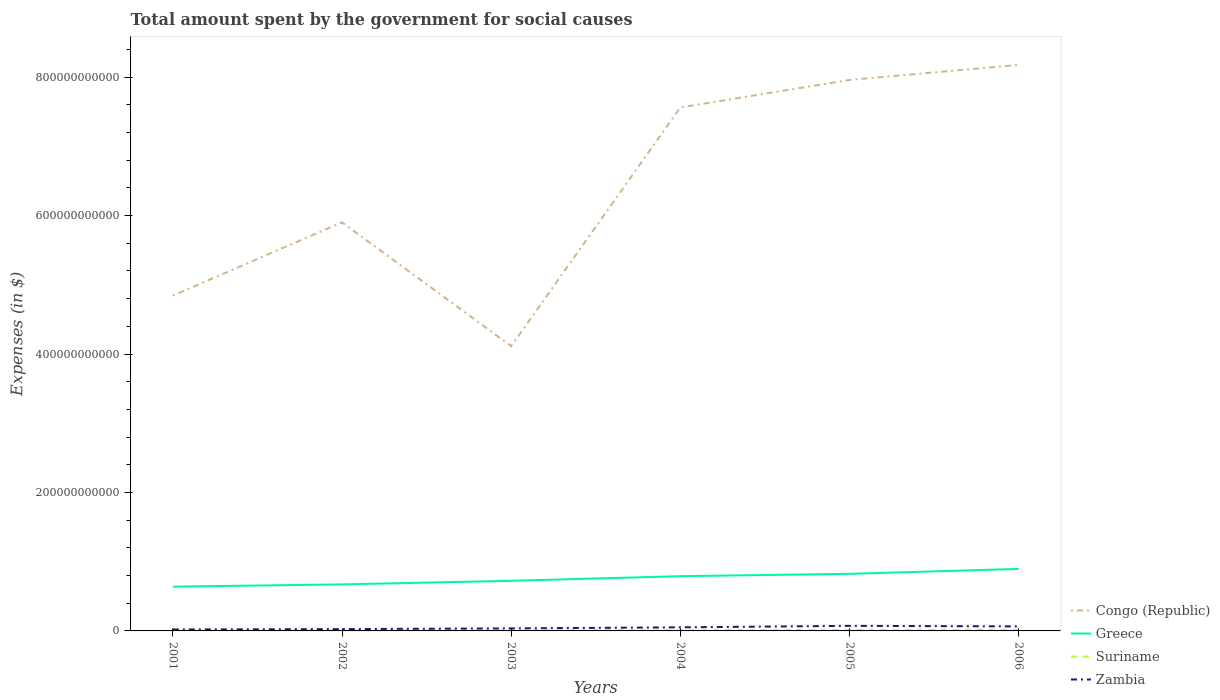Is the number of lines equal to the number of legend labels?
Your answer should be very brief. Yes. Across all years, what is the maximum amount spent for social causes by the government in Congo (Republic)?
Offer a very short reply. 4.11e+11. In which year was the amount spent for social causes by the government in Suriname maximum?
Give a very brief answer. 2001. What is the total amount spent for social causes by the government in Greece in the graph?
Offer a very short reply. -1.01e+1. What is the difference between the highest and the second highest amount spent for social causes by the government in Suriname?
Your answer should be compact. 1.08e+09. What is the difference between the highest and the lowest amount spent for social causes by the government in Congo (Republic)?
Offer a very short reply. 3. How many years are there in the graph?
Keep it short and to the point. 6. What is the difference between two consecutive major ticks on the Y-axis?
Your answer should be compact. 2.00e+11. Are the values on the major ticks of Y-axis written in scientific E-notation?
Your response must be concise. No. Does the graph contain grids?
Give a very brief answer. No. How many legend labels are there?
Your answer should be compact. 4. What is the title of the graph?
Give a very brief answer. Total amount spent by the government for social causes. What is the label or title of the Y-axis?
Make the answer very short. Expenses (in $). What is the Expenses (in $) of Congo (Republic) in 2001?
Offer a very short reply. 4.84e+11. What is the Expenses (in $) in Greece in 2001?
Keep it short and to the point. 6.39e+1. What is the Expenses (in $) in Suriname in 2001?
Your answer should be compact. 5.43e+08. What is the Expenses (in $) of Zambia in 2001?
Give a very brief answer. 2.09e+09. What is the Expenses (in $) in Congo (Republic) in 2002?
Your answer should be compact. 5.90e+11. What is the Expenses (in $) in Greece in 2002?
Make the answer very short. 6.72e+1. What is the Expenses (in $) of Suriname in 2002?
Make the answer very short. 7.52e+08. What is the Expenses (in $) in Zambia in 2002?
Offer a terse response. 2.61e+09. What is the Expenses (in $) in Congo (Republic) in 2003?
Your response must be concise. 4.11e+11. What is the Expenses (in $) in Greece in 2003?
Make the answer very short. 7.24e+1. What is the Expenses (in $) in Suriname in 2003?
Ensure brevity in your answer.  8.44e+08. What is the Expenses (in $) of Zambia in 2003?
Your response must be concise. 3.65e+09. What is the Expenses (in $) of Congo (Republic) in 2004?
Your response must be concise. 7.56e+11. What is the Expenses (in $) in Greece in 2004?
Make the answer very short. 7.91e+1. What is the Expenses (in $) in Suriname in 2004?
Offer a very short reply. 1.07e+09. What is the Expenses (in $) of Zambia in 2004?
Offer a terse response. 5.19e+09. What is the Expenses (in $) in Congo (Republic) in 2005?
Your answer should be very brief. 7.96e+11. What is the Expenses (in $) of Greece in 2005?
Make the answer very short. 8.25e+1. What is the Expenses (in $) in Suriname in 2005?
Give a very brief answer. 1.28e+09. What is the Expenses (in $) of Zambia in 2005?
Offer a very short reply. 7.35e+09. What is the Expenses (in $) in Congo (Republic) in 2006?
Ensure brevity in your answer.  8.18e+11. What is the Expenses (in $) in Greece in 2006?
Offer a terse response. 8.96e+1. What is the Expenses (in $) of Suriname in 2006?
Your response must be concise. 1.63e+09. What is the Expenses (in $) of Zambia in 2006?
Your response must be concise. 6.54e+09. Across all years, what is the maximum Expenses (in $) in Congo (Republic)?
Keep it short and to the point. 8.18e+11. Across all years, what is the maximum Expenses (in $) in Greece?
Make the answer very short. 8.96e+1. Across all years, what is the maximum Expenses (in $) in Suriname?
Ensure brevity in your answer.  1.63e+09. Across all years, what is the maximum Expenses (in $) of Zambia?
Make the answer very short. 7.35e+09. Across all years, what is the minimum Expenses (in $) of Congo (Republic)?
Keep it short and to the point. 4.11e+11. Across all years, what is the minimum Expenses (in $) in Greece?
Your response must be concise. 6.39e+1. Across all years, what is the minimum Expenses (in $) of Suriname?
Make the answer very short. 5.43e+08. Across all years, what is the minimum Expenses (in $) of Zambia?
Offer a terse response. 2.09e+09. What is the total Expenses (in $) of Congo (Republic) in the graph?
Ensure brevity in your answer.  3.86e+12. What is the total Expenses (in $) of Greece in the graph?
Offer a very short reply. 4.55e+11. What is the total Expenses (in $) in Suriname in the graph?
Keep it short and to the point. 6.12e+09. What is the total Expenses (in $) in Zambia in the graph?
Ensure brevity in your answer.  2.74e+1. What is the difference between the Expenses (in $) of Congo (Republic) in 2001 and that in 2002?
Make the answer very short. -1.06e+11. What is the difference between the Expenses (in $) of Greece in 2001 and that in 2002?
Offer a very short reply. -3.33e+09. What is the difference between the Expenses (in $) in Suriname in 2001 and that in 2002?
Your response must be concise. -2.09e+08. What is the difference between the Expenses (in $) in Zambia in 2001 and that in 2002?
Your answer should be very brief. -5.29e+08. What is the difference between the Expenses (in $) in Congo (Republic) in 2001 and that in 2003?
Make the answer very short. 7.30e+1. What is the difference between the Expenses (in $) in Greece in 2001 and that in 2003?
Offer a terse response. -8.49e+09. What is the difference between the Expenses (in $) in Suriname in 2001 and that in 2003?
Your response must be concise. -3.00e+08. What is the difference between the Expenses (in $) in Zambia in 2001 and that in 2003?
Provide a succinct answer. -1.57e+09. What is the difference between the Expenses (in $) of Congo (Republic) in 2001 and that in 2004?
Ensure brevity in your answer.  -2.72e+11. What is the difference between the Expenses (in $) in Greece in 2001 and that in 2004?
Provide a short and direct response. -1.52e+1. What is the difference between the Expenses (in $) in Suriname in 2001 and that in 2004?
Provide a succinct answer. -5.28e+08. What is the difference between the Expenses (in $) in Zambia in 2001 and that in 2004?
Offer a very short reply. -3.10e+09. What is the difference between the Expenses (in $) of Congo (Republic) in 2001 and that in 2005?
Provide a short and direct response. -3.12e+11. What is the difference between the Expenses (in $) of Greece in 2001 and that in 2005?
Your answer should be very brief. -1.86e+1. What is the difference between the Expenses (in $) in Suriname in 2001 and that in 2005?
Make the answer very short. -7.40e+08. What is the difference between the Expenses (in $) of Zambia in 2001 and that in 2005?
Offer a terse response. -5.26e+09. What is the difference between the Expenses (in $) of Congo (Republic) in 2001 and that in 2006?
Provide a short and direct response. -3.33e+11. What is the difference between the Expenses (in $) in Greece in 2001 and that in 2006?
Provide a short and direct response. -2.57e+1. What is the difference between the Expenses (in $) of Suriname in 2001 and that in 2006?
Offer a terse response. -1.08e+09. What is the difference between the Expenses (in $) of Zambia in 2001 and that in 2006?
Your answer should be very brief. -4.46e+09. What is the difference between the Expenses (in $) of Congo (Republic) in 2002 and that in 2003?
Provide a succinct answer. 1.79e+11. What is the difference between the Expenses (in $) of Greece in 2002 and that in 2003?
Your answer should be compact. -5.16e+09. What is the difference between the Expenses (in $) in Suriname in 2002 and that in 2003?
Your response must be concise. -9.11e+07. What is the difference between the Expenses (in $) of Zambia in 2002 and that in 2003?
Ensure brevity in your answer.  -1.04e+09. What is the difference between the Expenses (in $) in Congo (Republic) in 2002 and that in 2004?
Make the answer very short. -1.66e+11. What is the difference between the Expenses (in $) of Greece in 2002 and that in 2004?
Offer a terse response. -1.19e+1. What is the difference between the Expenses (in $) of Suriname in 2002 and that in 2004?
Keep it short and to the point. -3.19e+08. What is the difference between the Expenses (in $) in Zambia in 2002 and that in 2004?
Your answer should be compact. -2.57e+09. What is the difference between the Expenses (in $) of Congo (Republic) in 2002 and that in 2005?
Keep it short and to the point. -2.06e+11. What is the difference between the Expenses (in $) of Greece in 2002 and that in 2005?
Give a very brief answer. -1.52e+1. What is the difference between the Expenses (in $) of Suriname in 2002 and that in 2005?
Provide a succinct answer. -5.31e+08. What is the difference between the Expenses (in $) of Zambia in 2002 and that in 2005?
Your answer should be compact. -4.73e+09. What is the difference between the Expenses (in $) of Congo (Republic) in 2002 and that in 2006?
Your answer should be compact. -2.28e+11. What is the difference between the Expenses (in $) of Greece in 2002 and that in 2006?
Offer a very short reply. -2.23e+1. What is the difference between the Expenses (in $) in Suriname in 2002 and that in 2006?
Ensure brevity in your answer.  -8.74e+08. What is the difference between the Expenses (in $) in Zambia in 2002 and that in 2006?
Your response must be concise. -3.93e+09. What is the difference between the Expenses (in $) of Congo (Republic) in 2003 and that in 2004?
Provide a short and direct response. -3.45e+11. What is the difference between the Expenses (in $) of Greece in 2003 and that in 2004?
Offer a terse response. -6.69e+09. What is the difference between the Expenses (in $) in Suriname in 2003 and that in 2004?
Give a very brief answer. -2.28e+08. What is the difference between the Expenses (in $) in Zambia in 2003 and that in 2004?
Offer a terse response. -1.53e+09. What is the difference between the Expenses (in $) in Congo (Republic) in 2003 and that in 2005?
Offer a very short reply. -3.85e+11. What is the difference between the Expenses (in $) of Greece in 2003 and that in 2005?
Provide a short and direct response. -1.01e+1. What is the difference between the Expenses (in $) in Suriname in 2003 and that in 2005?
Offer a very short reply. -4.39e+08. What is the difference between the Expenses (in $) of Zambia in 2003 and that in 2005?
Keep it short and to the point. -3.69e+09. What is the difference between the Expenses (in $) in Congo (Republic) in 2003 and that in 2006?
Provide a short and direct response. -4.06e+11. What is the difference between the Expenses (in $) in Greece in 2003 and that in 2006?
Provide a short and direct response. -1.72e+1. What is the difference between the Expenses (in $) of Suriname in 2003 and that in 2006?
Offer a very short reply. -7.83e+08. What is the difference between the Expenses (in $) of Zambia in 2003 and that in 2006?
Your answer should be compact. -2.89e+09. What is the difference between the Expenses (in $) of Congo (Republic) in 2004 and that in 2005?
Give a very brief answer. -3.97e+1. What is the difference between the Expenses (in $) of Greece in 2004 and that in 2005?
Provide a short and direct response. -3.38e+09. What is the difference between the Expenses (in $) in Suriname in 2004 and that in 2005?
Make the answer very short. -2.11e+08. What is the difference between the Expenses (in $) in Zambia in 2004 and that in 2005?
Offer a terse response. -2.16e+09. What is the difference between the Expenses (in $) in Congo (Republic) in 2004 and that in 2006?
Give a very brief answer. -6.15e+1. What is the difference between the Expenses (in $) in Greece in 2004 and that in 2006?
Give a very brief answer. -1.05e+1. What is the difference between the Expenses (in $) of Suriname in 2004 and that in 2006?
Keep it short and to the point. -5.55e+08. What is the difference between the Expenses (in $) in Zambia in 2004 and that in 2006?
Your answer should be very brief. -1.36e+09. What is the difference between the Expenses (in $) in Congo (Republic) in 2005 and that in 2006?
Ensure brevity in your answer.  -2.18e+1. What is the difference between the Expenses (in $) of Greece in 2005 and that in 2006?
Provide a succinct answer. -7.10e+09. What is the difference between the Expenses (in $) in Suriname in 2005 and that in 2006?
Provide a succinct answer. -3.43e+08. What is the difference between the Expenses (in $) in Zambia in 2005 and that in 2006?
Offer a very short reply. 8.04e+08. What is the difference between the Expenses (in $) in Congo (Republic) in 2001 and the Expenses (in $) in Greece in 2002?
Provide a short and direct response. 4.17e+11. What is the difference between the Expenses (in $) in Congo (Republic) in 2001 and the Expenses (in $) in Suriname in 2002?
Ensure brevity in your answer.  4.84e+11. What is the difference between the Expenses (in $) of Congo (Republic) in 2001 and the Expenses (in $) of Zambia in 2002?
Your answer should be compact. 4.82e+11. What is the difference between the Expenses (in $) of Greece in 2001 and the Expenses (in $) of Suriname in 2002?
Give a very brief answer. 6.32e+1. What is the difference between the Expenses (in $) of Greece in 2001 and the Expenses (in $) of Zambia in 2002?
Your answer should be compact. 6.13e+1. What is the difference between the Expenses (in $) of Suriname in 2001 and the Expenses (in $) of Zambia in 2002?
Provide a short and direct response. -2.07e+09. What is the difference between the Expenses (in $) in Congo (Republic) in 2001 and the Expenses (in $) in Greece in 2003?
Your answer should be compact. 4.12e+11. What is the difference between the Expenses (in $) of Congo (Republic) in 2001 and the Expenses (in $) of Suriname in 2003?
Provide a short and direct response. 4.84e+11. What is the difference between the Expenses (in $) in Congo (Republic) in 2001 and the Expenses (in $) in Zambia in 2003?
Make the answer very short. 4.81e+11. What is the difference between the Expenses (in $) of Greece in 2001 and the Expenses (in $) of Suriname in 2003?
Your answer should be very brief. 6.31e+1. What is the difference between the Expenses (in $) of Greece in 2001 and the Expenses (in $) of Zambia in 2003?
Make the answer very short. 6.03e+1. What is the difference between the Expenses (in $) in Suriname in 2001 and the Expenses (in $) in Zambia in 2003?
Make the answer very short. -3.11e+09. What is the difference between the Expenses (in $) in Congo (Republic) in 2001 and the Expenses (in $) in Greece in 2004?
Make the answer very short. 4.05e+11. What is the difference between the Expenses (in $) of Congo (Republic) in 2001 and the Expenses (in $) of Suriname in 2004?
Offer a terse response. 4.83e+11. What is the difference between the Expenses (in $) in Congo (Republic) in 2001 and the Expenses (in $) in Zambia in 2004?
Give a very brief answer. 4.79e+11. What is the difference between the Expenses (in $) of Greece in 2001 and the Expenses (in $) of Suriname in 2004?
Make the answer very short. 6.28e+1. What is the difference between the Expenses (in $) of Greece in 2001 and the Expenses (in $) of Zambia in 2004?
Offer a terse response. 5.87e+1. What is the difference between the Expenses (in $) of Suriname in 2001 and the Expenses (in $) of Zambia in 2004?
Make the answer very short. -4.64e+09. What is the difference between the Expenses (in $) of Congo (Republic) in 2001 and the Expenses (in $) of Greece in 2005?
Keep it short and to the point. 4.02e+11. What is the difference between the Expenses (in $) of Congo (Republic) in 2001 and the Expenses (in $) of Suriname in 2005?
Give a very brief answer. 4.83e+11. What is the difference between the Expenses (in $) of Congo (Republic) in 2001 and the Expenses (in $) of Zambia in 2005?
Ensure brevity in your answer.  4.77e+11. What is the difference between the Expenses (in $) in Greece in 2001 and the Expenses (in $) in Suriname in 2005?
Give a very brief answer. 6.26e+1. What is the difference between the Expenses (in $) in Greece in 2001 and the Expenses (in $) in Zambia in 2005?
Make the answer very short. 5.66e+1. What is the difference between the Expenses (in $) of Suriname in 2001 and the Expenses (in $) of Zambia in 2005?
Ensure brevity in your answer.  -6.80e+09. What is the difference between the Expenses (in $) of Congo (Republic) in 2001 and the Expenses (in $) of Greece in 2006?
Offer a terse response. 3.95e+11. What is the difference between the Expenses (in $) in Congo (Republic) in 2001 and the Expenses (in $) in Suriname in 2006?
Your answer should be compact. 4.83e+11. What is the difference between the Expenses (in $) of Congo (Republic) in 2001 and the Expenses (in $) of Zambia in 2006?
Ensure brevity in your answer.  4.78e+11. What is the difference between the Expenses (in $) of Greece in 2001 and the Expenses (in $) of Suriname in 2006?
Ensure brevity in your answer.  6.23e+1. What is the difference between the Expenses (in $) in Greece in 2001 and the Expenses (in $) in Zambia in 2006?
Your response must be concise. 5.74e+1. What is the difference between the Expenses (in $) in Suriname in 2001 and the Expenses (in $) in Zambia in 2006?
Provide a short and direct response. -6.00e+09. What is the difference between the Expenses (in $) in Congo (Republic) in 2002 and the Expenses (in $) in Greece in 2003?
Provide a short and direct response. 5.18e+11. What is the difference between the Expenses (in $) of Congo (Republic) in 2002 and the Expenses (in $) of Suriname in 2003?
Your answer should be compact. 5.89e+11. What is the difference between the Expenses (in $) of Congo (Republic) in 2002 and the Expenses (in $) of Zambia in 2003?
Provide a short and direct response. 5.87e+11. What is the difference between the Expenses (in $) in Greece in 2002 and the Expenses (in $) in Suriname in 2003?
Your answer should be very brief. 6.64e+1. What is the difference between the Expenses (in $) of Greece in 2002 and the Expenses (in $) of Zambia in 2003?
Provide a succinct answer. 6.36e+1. What is the difference between the Expenses (in $) in Suriname in 2002 and the Expenses (in $) in Zambia in 2003?
Your response must be concise. -2.90e+09. What is the difference between the Expenses (in $) of Congo (Republic) in 2002 and the Expenses (in $) of Greece in 2004?
Keep it short and to the point. 5.11e+11. What is the difference between the Expenses (in $) of Congo (Republic) in 2002 and the Expenses (in $) of Suriname in 2004?
Ensure brevity in your answer.  5.89e+11. What is the difference between the Expenses (in $) in Congo (Republic) in 2002 and the Expenses (in $) in Zambia in 2004?
Offer a very short reply. 5.85e+11. What is the difference between the Expenses (in $) of Greece in 2002 and the Expenses (in $) of Suriname in 2004?
Offer a very short reply. 6.62e+1. What is the difference between the Expenses (in $) in Greece in 2002 and the Expenses (in $) in Zambia in 2004?
Your response must be concise. 6.21e+1. What is the difference between the Expenses (in $) of Suriname in 2002 and the Expenses (in $) of Zambia in 2004?
Your answer should be very brief. -4.43e+09. What is the difference between the Expenses (in $) of Congo (Republic) in 2002 and the Expenses (in $) of Greece in 2005?
Offer a very short reply. 5.08e+11. What is the difference between the Expenses (in $) of Congo (Republic) in 2002 and the Expenses (in $) of Suriname in 2005?
Provide a succinct answer. 5.89e+11. What is the difference between the Expenses (in $) of Congo (Republic) in 2002 and the Expenses (in $) of Zambia in 2005?
Ensure brevity in your answer.  5.83e+11. What is the difference between the Expenses (in $) in Greece in 2002 and the Expenses (in $) in Suriname in 2005?
Give a very brief answer. 6.60e+1. What is the difference between the Expenses (in $) in Greece in 2002 and the Expenses (in $) in Zambia in 2005?
Offer a very short reply. 5.99e+1. What is the difference between the Expenses (in $) in Suriname in 2002 and the Expenses (in $) in Zambia in 2005?
Offer a terse response. -6.60e+09. What is the difference between the Expenses (in $) of Congo (Republic) in 2002 and the Expenses (in $) of Greece in 2006?
Keep it short and to the point. 5.01e+11. What is the difference between the Expenses (in $) in Congo (Republic) in 2002 and the Expenses (in $) in Suriname in 2006?
Your answer should be very brief. 5.89e+11. What is the difference between the Expenses (in $) of Congo (Republic) in 2002 and the Expenses (in $) of Zambia in 2006?
Ensure brevity in your answer.  5.84e+11. What is the difference between the Expenses (in $) of Greece in 2002 and the Expenses (in $) of Suriname in 2006?
Provide a succinct answer. 6.56e+1. What is the difference between the Expenses (in $) in Greece in 2002 and the Expenses (in $) in Zambia in 2006?
Make the answer very short. 6.07e+1. What is the difference between the Expenses (in $) of Suriname in 2002 and the Expenses (in $) of Zambia in 2006?
Give a very brief answer. -5.79e+09. What is the difference between the Expenses (in $) in Congo (Republic) in 2003 and the Expenses (in $) in Greece in 2004?
Give a very brief answer. 3.32e+11. What is the difference between the Expenses (in $) in Congo (Republic) in 2003 and the Expenses (in $) in Suriname in 2004?
Ensure brevity in your answer.  4.10e+11. What is the difference between the Expenses (in $) of Congo (Republic) in 2003 and the Expenses (in $) of Zambia in 2004?
Provide a short and direct response. 4.06e+11. What is the difference between the Expenses (in $) of Greece in 2003 and the Expenses (in $) of Suriname in 2004?
Your answer should be very brief. 7.13e+1. What is the difference between the Expenses (in $) in Greece in 2003 and the Expenses (in $) in Zambia in 2004?
Your answer should be very brief. 6.72e+1. What is the difference between the Expenses (in $) of Suriname in 2003 and the Expenses (in $) of Zambia in 2004?
Provide a short and direct response. -4.34e+09. What is the difference between the Expenses (in $) in Congo (Republic) in 2003 and the Expenses (in $) in Greece in 2005?
Offer a very short reply. 3.29e+11. What is the difference between the Expenses (in $) in Congo (Republic) in 2003 and the Expenses (in $) in Suriname in 2005?
Give a very brief answer. 4.10e+11. What is the difference between the Expenses (in $) of Congo (Republic) in 2003 and the Expenses (in $) of Zambia in 2005?
Your response must be concise. 4.04e+11. What is the difference between the Expenses (in $) of Greece in 2003 and the Expenses (in $) of Suriname in 2005?
Ensure brevity in your answer.  7.11e+1. What is the difference between the Expenses (in $) in Greece in 2003 and the Expenses (in $) in Zambia in 2005?
Offer a terse response. 6.51e+1. What is the difference between the Expenses (in $) in Suriname in 2003 and the Expenses (in $) in Zambia in 2005?
Your response must be concise. -6.50e+09. What is the difference between the Expenses (in $) of Congo (Republic) in 2003 and the Expenses (in $) of Greece in 2006?
Your response must be concise. 3.22e+11. What is the difference between the Expenses (in $) of Congo (Republic) in 2003 and the Expenses (in $) of Suriname in 2006?
Make the answer very short. 4.10e+11. What is the difference between the Expenses (in $) of Congo (Republic) in 2003 and the Expenses (in $) of Zambia in 2006?
Offer a very short reply. 4.05e+11. What is the difference between the Expenses (in $) of Greece in 2003 and the Expenses (in $) of Suriname in 2006?
Provide a succinct answer. 7.08e+1. What is the difference between the Expenses (in $) in Greece in 2003 and the Expenses (in $) in Zambia in 2006?
Keep it short and to the point. 6.59e+1. What is the difference between the Expenses (in $) in Suriname in 2003 and the Expenses (in $) in Zambia in 2006?
Give a very brief answer. -5.70e+09. What is the difference between the Expenses (in $) in Congo (Republic) in 2004 and the Expenses (in $) in Greece in 2005?
Provide a short and direct response. 6.74e+11. What is the difference between the Expenses (in $) of Congo (Republic) in 2004 and the Expenses (in $) of Suriname in 2005?
Your answer should be very brief. 7.55e+11. What is the difference between the Expenses (in $) of Congo (Republic) in 2004 and the Expenses (in $) of Zambia in 2005?
Your answer should be compact. 7.49e+11. What is the difference between the Expenses (in $) in Greece in 2004 and the Expenses (in $) in Suriname in 2005?
Make the answer very short. 7.78e+1. What is the difference between the Expenses (in $) in Greece in 2004 and the Expenses (in $) in Zambia in 2005?
Your answer should be very brief. 7.17e+1. What is the difference between the Expenses (in $) of Suriname in 2004 and the Expenses (in $) of Zambia in 2005?
Keep it short and to the point. -6.28e+09. What is the difference between the Expenses (in $) in Congo (Republic) in 2004 and the Expenses (in $) in Greece in 2006?
Offer a very short reply. 6.67e+11. What is the difference between the Expenses (in $) of Congo (Republic) in 2004 and the Expenses (in $) of Suriname in 2006?
Give a very brief answer. 7.55e+11. What is the difference between the Expenses (in $) in Congo (Republic) in 2004 and the Expenses (in $) in Zambia in 2006?
Your answer should be very brief. 7.50e+11. What is the difference between the Expenses (in $) of Greece in 2004 and the Expenses (in $) of Suriname in 2006?
Provide a short and direct response. 7.75e+1. What is the difference between the Expenses (in $) in Greece in 2004 and the Expenses (in $) in Zambia in 2006?
Provide a succinct answer. 7.25e+1. What is the difference between the Expenses (in $) in Suriname in 2004 and the Expenses (in $) in Zambia in 2006?
Give a very brief answer. -5.47e+09. What is the difference between the Expenses (in $) of Congo (Republic) in 2005 and the Expenses (in $) of Greece in 2006?
Provide a succinct answer. 7.06e+11. What is the difference between the Expenses (in $) in Congo (Republic) in 2005 and the Expenses (in $) in Suriname in 2006?
Make the answer very short. 7.94e+11. What is the difference between the Expenses (in $) in Congo (Republic) in 2005 and the Expenses (in $) in Zambia in 2006?
Provide a short and direct response. 7.89e+11. What is the difference between the Expenses (in $) of Greece in 2005 and the Expenses (in $) of Suriname in 2006?
Keep it short and to the point. 8.08e+1. What is the difference between the Expenses (in $) in Greece in 2005 and the Expenses (in $) in Zambia in 2006?
Make the answer very short. 7.59e+1. What is the difference between the Expenses (in $) of Suriname in 2005 and the Expenses (in $) of Zambia in 2006?
Provide a succinct answer. -5.26e+09. What is the average Expenses (in $) in Congo (Republic) per year?
Make the answer very short. 6.43e+11. What is the average Expenses (in $) of Greece per year?
Make the answer very short. 7.58e+1. What is the average Expenses (in $) of Suriname per year?
Provide a succinct answer. 1.02e+09. What is the average Expenses (in $) in Zambia per year?
Make the answer very short. 4.57e+09. In the year 2001, what is the difference between the Expenses (in $) in Congo (Republic) and Expenses (in $) in Greece?
Make the answer very short. 4.21e+11. In the year 2001, what is the difference between the Expenses (in $) of Congo (Republic) and Expenses (in $) of Suriname?
Make the answer very short. 4.84e+11. In the year 2001, what is the difference between the Expenses (in $) of Congo (Republic) and Expenses (in $) of Zambia?
Your response must be concise. 4.82e+11. In the year 2001, what is the difference between the Expenses (in $) in Greece and Expenses (in $) in Suriname?
Keep it short and to the point. 6.34e+1. In the year 2001, what is the difference between the Expenses (in $) of Greece and Expenses (in $) of Zambia?
Your answer should be very brief. 6.18e+1. In the year 2001, what is the difference between the Expenses (in $) in Suriname and Expenses (in $) in Zambia?
Provide a succinct answer. -1.54e+09. In the year 2002, what is the difference between the Expenses (in $) of Congo (Republic) and Expenses (in $) of Greece?
Provide a short and direct response. 5.23e+11. In the year 2002, what is the difference between the Expenses (in $) in Congo (Republic) and Expenses (in $) in Suriname?
Keep it short and to the point. 5.89e+11. In the year 2002, what is the difference between the Expenses (in $) of Congo (Republic) and Expenses (in $) of Zambia?
Your answer should be compact. 5.88e+11. In the year 2002, what is the difference between the Expenses (in $) in Greece and Expenses (in $) in Suriname?
Your response must be concise. 6.65e+1. In the year 2002, what is the difference between the Expenses (in $) in Greece and Expenses (in $) in Zambia?
Make the answer very short. 6.46e+1. In the year 2002, what is the difference between the Expenses (in $) in Suriname and Expenses (in $) in Zambia?
Your response must be concise. -1.86e+09. In the year 2003, what is the difference between the Expenses (in $) of Congo (Republic) and Expenses (in $) of Greece?
Offer a terse response. 3.39e+11. In the year 2003, what is the difference between the Expenses (in $) in Congo (Republic) and Expenses (in $) in Suriname?
Provide a succinct answer. 4.11e+11. In the year 2003, what is the difference between the Expenses (in $) in Congo (Republic) and Expenses (in $) in Zambia?
Your answer should be compact. 4.08e+11. In the year 2003, what is the difference between the Expenses (in $) in Greece and Expenses (in $) in Suriname?
Give a very brief answer. 7.16e+1. In the year 2003, what is the difference between the Expenses (in $) in Greece and Expenses (in $) in Zambia?
Offer a terse response. 6.87e+1. In the year 2003, what is the difference between the Expenses (in $) of Suriname and Expenses (in $) of Zambia?
Provide a succinct answer. -2.81e+09. In the year 2004, what is the difference between the Expenses (in $) in Congo (Republic) and Expenses (in $) in Greece?
Your answer should be compact. 6.77e+11. In the year 2004, what is the difference between the Expenses (in $) of Congo (Republic) and Expenses (in $) of Suriname?
Provide a succinct answer. 7.55e+11. In the year 2004, what is the difference between the Expenses (in $) in Congo (Republic) and Expenses (in $) in Zambia?
Ensure brevity in your answer.  7.51e+11. In the year 2004, what is the difference between the Expenses (in $) in Greece and Expenses (in $) in Suriname?
Make the answer very short. 7.80e+1. In the year 2004, what is the difference between the Expenses (in $) of Greece and Expenses (in $) of Zambia?
Offer a very short reply. 7.39e+1. In the year 2004, what is the difference between the Expenses (in $) of Suriname and Expenses (in $) of Zambia?
Keep it short and to the point. -4.12e+09. In the year 2005, what is the difference between the Expenses (in $) in Congo (Republic) and Expenses (in $) in Greece?
Offer a very short reply. 7.13e+11. In the year 2005, what is the difference between the Expenses (in $) of Congo (Republic) and Expenses (in $) of Suriname?
Provide a succinct answer. 7.95e+11. In the year 2005, what is the difference between the Expenses (in $) in Congo (Republic) and Expenses (in $) in Zambia?
Your answer should be very brief. 7.89e+11. In the year 2005, what is the difference between the Expenses (in $) in Greece and Expenses (in $) in Suriname?
Keep it short and to the point. 8.12e+1. In the year 2005, what is the difference between the Expenses (in $) of Greece and Expenses (in $) of Zambia?
Make the answer very short. 7.51e+1. In the year 2005, what is the difference between the Expenses (in $) in Suriname and Expenses (in $) in Zambia?
Give a very brief answer. -6.06e+09. In the year 2006, what is the difference between the Expenses (in $) of Congo (Republic) and Expenses (in $) of Greece?
Your response must be concise. 7.28e+11. In the year 2006, what is the difference between the Expenses (in $) of Congo (Republic) and Expenses (in $) of Suriname?
Keep it short and to the point. 8.16e+11. In the year 2006, what is the difference between the Expenses (in $) in Congo (Republic) and Expenses (in $) in Zambia?
Make the answer very short. 8.11e+11. In the year 2006, what is the difference between the Expenses (in $) in Greece and Expenses (in $) in Suriname?
Offer a terse response. 8.79e+1. In the year 2006, what is the difference between the Expenses (in $) of Greece and Expenses (in $) of Zambia?
Your answer should be compact. 8.30e+1. In the year 2006, what is the difference between the Expenses (in $) in Suriname and Expenses (in $) in Zambia?
Offer a terse response. -4.92e+09. What is the ratio of the Expenses (in $) in Congo (Republic) in 2001 to that in 2002?
Give a very brief answer. 0.82. What is the ratio of the Expenses (in $) of Greece in 2001 to that in 2002?
Offer a terse response. 0.95. What is the ratio of the Expenses (in $) in Suriname in 2001 to that in 2002?
Your answer should be compact. 0.72. What is the ratio of the Expenses (in $) of Zambia in 2001 to that in 2002?
Provide a succinct answer. 0.8. What is the ratio of the Expenses (in $) in Congo (Republic) in 2001 to that in 2003?
Provide a succinct answer. 1.18. What is the ratio of the Expenses (in $) in Greece in 2001 to that in 2003?
Your answer should be compact. 0.88. What is the ratio of the Expenses (in $) of Suriname in 2001 to that in 2003?
Offer a very short reply. 0.64. What is the ratio of the Expenses (in $) in Zambia in 2001 to that in 2003?
Provide a short and direct response. 0.57. What is the ratio of the Expenses (in $) of Congo (Republic) in 2001 to that in 2004?
Keep it short and to the point. 0.64. What is the ratio of the Expenses (in $) of Greece in 2001 to that in 2004?
Your answer should be compact. 0.81. What is the ratio of the Expenses (in $) in Suriname in 2001 to that in 2004?
Your response must be concise. 0.51. What is the ratio of the Expenses (in $) in Zambia in 2001 to that in 2004?
Provide a short and direct response. 0.4. What is the ratio of the Expenses (in $) in Congo (Republic) in 2001 to that in 2005?
Ensure brevity in your answer.  0.61. What is the ratio of the Expenses (in $) in Greece in 2001 to that in 2005?
Keep it short and to the point. 0.77. What is the ratio of the Expenses (in $) of Suriname in 2001 to that in 2005?
Provide a succinct answer. 0.42. What is the ratio of the Expenses (in $) of Zambia in 2001 to that in 2005?
Make the answer very short. 0.28. What is the ratio of the Expenses (in $) of Congo (Republic) in 2001 to that in 2006?
Your answer should be compact. 0.59. What is the ratio of the Expenses (in $) of Greece in 2001 to that in 2006?
Provide a succinct answer. 0.71. What is the ratio of the Expenses (in $) of Suriname in 2001 to that in 2006?
Your answer should be very brief. 0.33. What is the ratio of the Expenses (in $) of Zambia in 2001 to that in 2006?
Give a very brief answer. 0.32. What is the ratio of the Expenses (in $) in Congo (Republic) in 2002 to that in 2003?
Provide a succinct answer. 1.43. What is the ratio of the Expenses (in $) in Greece in 2002 to that in 2003?
Provide a short and direct response. 0.93. What is the ratio of the Expenses (in $) of Suriname in 2002 to that in 2003?
Your answer should be very brief. 0.89. What is the ratio of the Expenses (in $) of Zambia in 2002 to that in 2003?
Provide a short and direct response. 0.72. What is the ratio of the Expenses (in $) in Congo (Republic) in 2002 to that in 2004?
Make the answer very short. 0.78. What is the ratio of the Expenses (in $) in Greece in 2002 to that in 2004?
Offer a terse response. 0.85. What is the ratio of the Expenses (in $) of Suriname in 2002 to that in 2004?
Your answer should be compact. 0.7. What is the ratio of the Expenses (in $) in Zambia in 2002 to that in 2004?
Give a very brief answer. 0.5. What is the ratio of the Expenses (in $) in Congo (Republic) in 2002 to that in 2005?
Give a very brief answer. 0.74. What is the ratio of the Expenses (in $) of Greece in 2002 to that in 2005?
Give a very brief answer. 0.82. What is the ratio of the Expenses (in $) in Suriname in 2002 to that in 2005?
Your answer should be compact. 0.59. What is the ratio of the Expenses (in $) in Zambia in 2002 to that in 2005?
Provide a succinct answer. 0.36. What is the ratio of the Expenses (in $) in Congo (Republic) in 2002 to that in 2006?
Give a very brief answer. 0.72. What is the ratio of the Expenses (in $) in Greece in 2002 to that in 2006?
Give a very brief answer. 0.75. What is the ratio of the Expenses (in $) of Suriname in 2002 to that in 2006?
Ensure brevity in your answer.  0.46. What is the ratio of the Expenses (in $) of Zambia in 2002 to that in 2006?
Give a very brief answer. 0.4. What is the ratio of the Expenses (in $) in Congo (Republic) in 2003 to that in 2004?
Provide a succinct answer. 0.54. What is the ratio of the Expenses (in $) in Greece in 2003 to that in 2004?
Keep it short and to the point. 0.92. What is the ratio of the Expenses (in $) of Suriname in 2003 to that in 2004?
Ensure brevity in your answer.  0.79. What is the ratio of the Expenses (in $) of Zambia in 2003 to that in 2004?
Keep it short and to the point. 0.7. What is the ratio of the Expenses (in $) of Congo (Republic) in 2003 to that in 2005?
Your answer should be very brief. 0.52. What is the ratio of the Expenses (in $) of Greece in 2003 to that in 2005?
Make the answer very short. 0.88. What is the ratio of the Expenses (in $) in Suriname in 2003 to that in 2005?
Offer a very short reply. 0.66. What is the ratio of the Expenses (in $) of Zambia in 2003 to that in 2005?
Offer a very short reply. 0.5. What is the ratio of the Expenses (in $) of Congo (Republic) in 2003 to that in 2006?
Provide a succinct answer. 0.5. What is the ratio of the Expenses (in $) in Greece in 2003 to that in 2006?
Offer a very short reply. 0.81. What is the ratio of the Expenses (in $) of Suriname in 2003 to that in 2006?
Your answer should be very brief. 0.52. What is the ratio of the Expenses (in $) in Zambia in 2003 to that in 2006?
Your answer should be compact. 0.56. What is the ratio of the Expenses (in $) in Congo (Republic) in 2004 to that in 2005?
Offer a very short reply. 0.95. What is the ratio of the Expenses (in $) of Greece in 2004 to that in 2005?
Provide a succinct answer. 0.96. What is the ratio of the Expenses (in $) of Suriname in 2004 to that in 2005?
Offer a very short reply. 0.84. What is the ratio of the Expenses (in $) of Zambia in 2004 to that in 2005?
Your answer should be very brief. 0.71. What is the ratio of the Expenses (in $) in Congo (Republic) in 2004 to that in 2006?
Keep it short and to the point. 0.92. What is the ratio of the Expenses (in $) in Greece in 2004 to that in 2006?
Give a very brief answer. 0.88. What is the ratio of the Expenses (in $) in Suriname in 2004 to that in 2006?
Provide a succinct answer. 0.66. What is the ratio of the Expenses (in $) of Zambia in 2004 to that in 2006?
Give a very brief answer. 0.79. What is the ratio of the Expenses (in $) in Congo (Republic) in 2005 to that in 2006?
Offer a terse response. 0.97. What is the ratio of the Expenses (in $) in Greece in 2005 to that in 2006?
Your answer should be very brief. 0.92. What is the ratio of the Expenses (in $) of Suriname in 2005 to that in 2006?
Offer a terse response. 0.79. What is the ratio of the Expenses (in $) in Zambia in 2005 to that in 2006?
Make the answer very short. 1.12. What is the difference between the highest and the second highest Expenses (in $) in Congo (Republic)?
Ensure brevity in your answer.  2.18e+1. What is the difference between the highest and the second highest Expenses (in $) in Greece?
Offer a very short reply. 7.10e+09. What is the difference between the highest and the second highest Expenses (in $) in Suriname?
Offer a very short reply. 3.43e+08. What is the difference between the highest and the second highest Expenses (in $) in Zambia?
Provide a short and direct response. 8.04e+08. What is the difference between the highest and the lowest Expenses (in $) of Congo (Republic)?
Your answer should be very brief. 4.06e+11. What is the difference between the highest and the lowest Expenses (in $) of Greece?
Offer a very short reply. 2.57e+1. What is the difference between the highest and the lowest Expenses (in $) of Suriname?
Offer a very short reply. 1.08e+09. What is the difference between the highest and the lowest Expenses (in $) in Zambia?
Keep it short and to the point. 5.26e+09. 